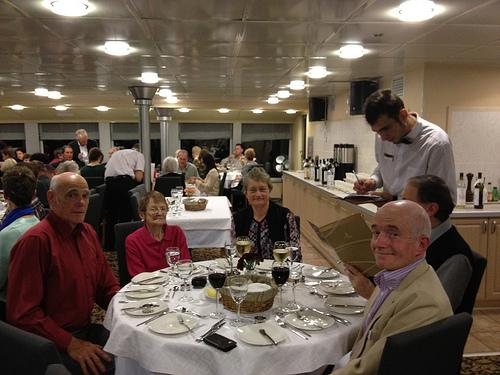What is the theme of the restaurant's lighting as seen in the image? The restaurant has rows of white lights on the ceiling, indicating a bright and elegant ambiance. What are the types of glasses present on the table? There are glasses of water and red wine on the table. What is the server in the white shirt doing? The server in the white shirt is taking orders from the diners using a notepad and pen. What do the old woman and the woman in black vest and glasses have in common? They both are wearing some form of a black outfit - a black vest for the one in glasses and a black multicolored outfit for the old woman. Describe the appearance and clothing of the old men in the image. The old men are twins, one is bald, and they are wearing a tan suit jacket, a purple striped shirt, and a dark red shirt. What items are placed on the countertop mentioned in the image? On the countertop, there are bottles, coffee urns, wines, and a black professional grade speaker. How many people can be seen in the image and what are they doing? There are several people seated around a table in a night-time restaurant, a waiter taking orders on a pad, and diners interacting with each other. Mention the various facial features mentioned in the image of a man and a woman. For the man: head, eye, mouth, ear, eyebrow, and hand. For the woman: head, nose, and a pair of glasses. What elements of the table setting can be seen in the image? Table settings include plates, silverware, white tablecloth, glasses of red wine and water, an open restaurant menu, and a bread basket. Tell me about the clothing of the man in the red shirt and the man turning and smiling. The man in the red shirt is wearing a dark red shirt, while the man turning and smiling is wearing a tan blazer and a striped purple shirt. 